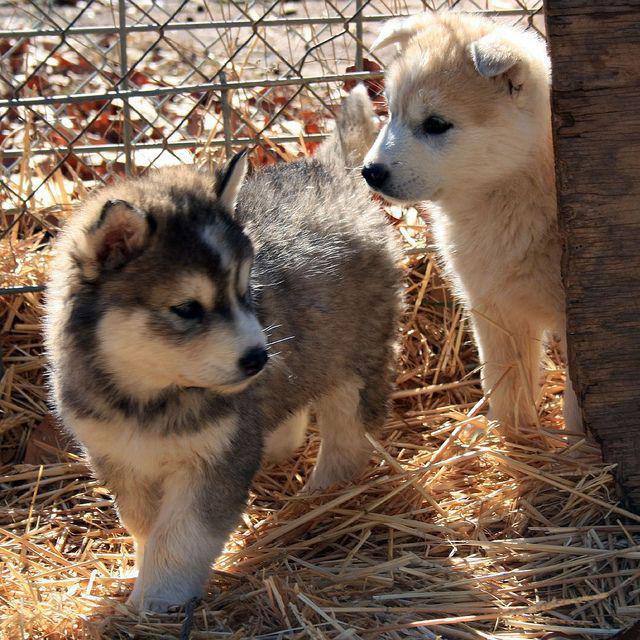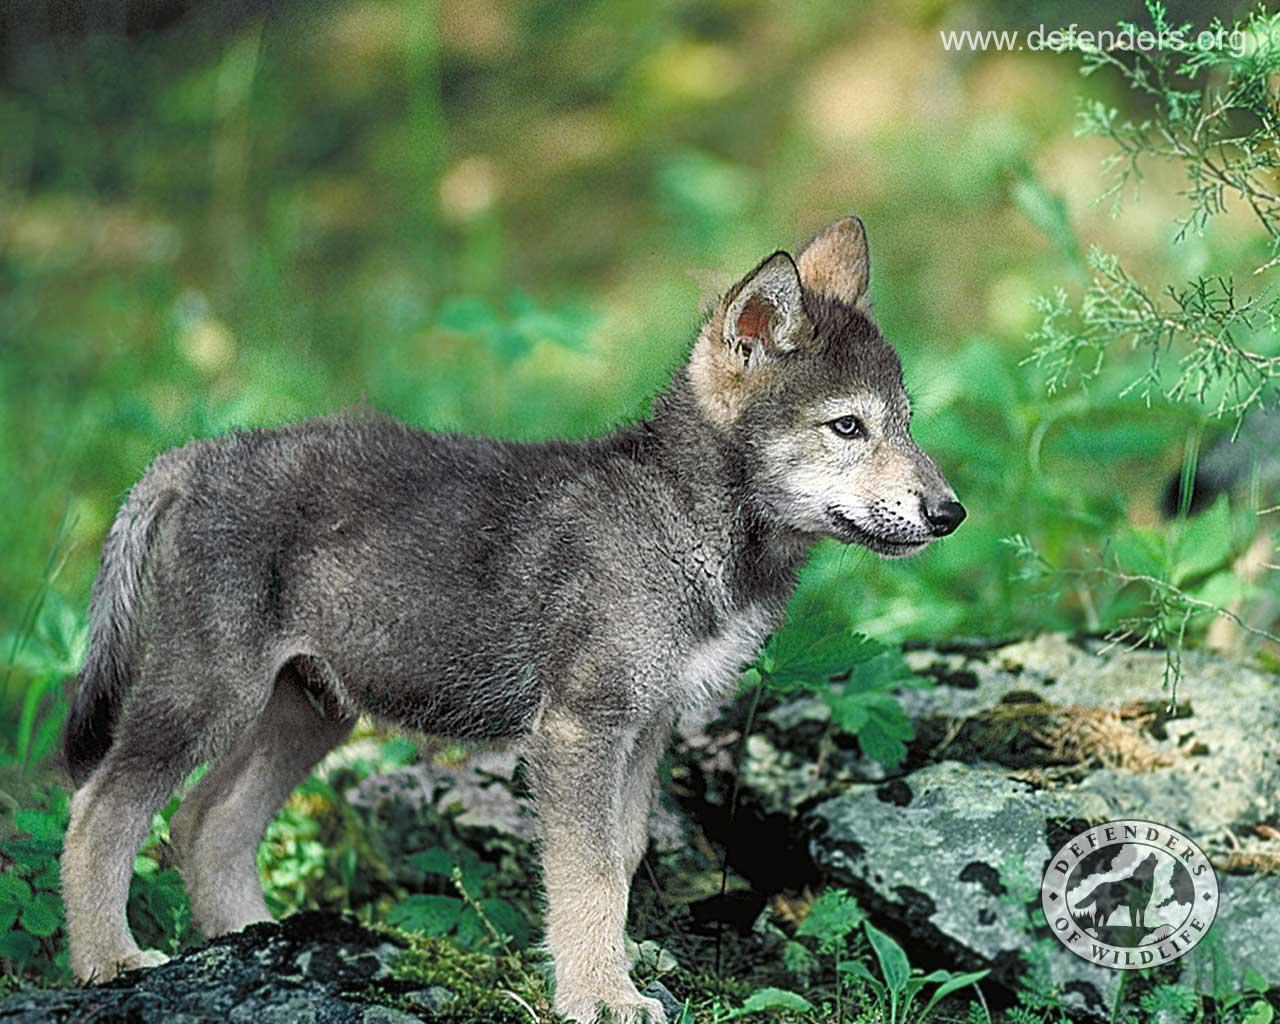The first image is the image on the left, the second image is the image on the right. For the images shown, is this caption "Fencing is in the background of one image." true? Answer yes or no. Yes. The first image is the image on the left, the second image is the image on the right. For the images shown, is this caption "Left image contains two dogs and right image contains one dog." true? Answer yes or no. Yes. 